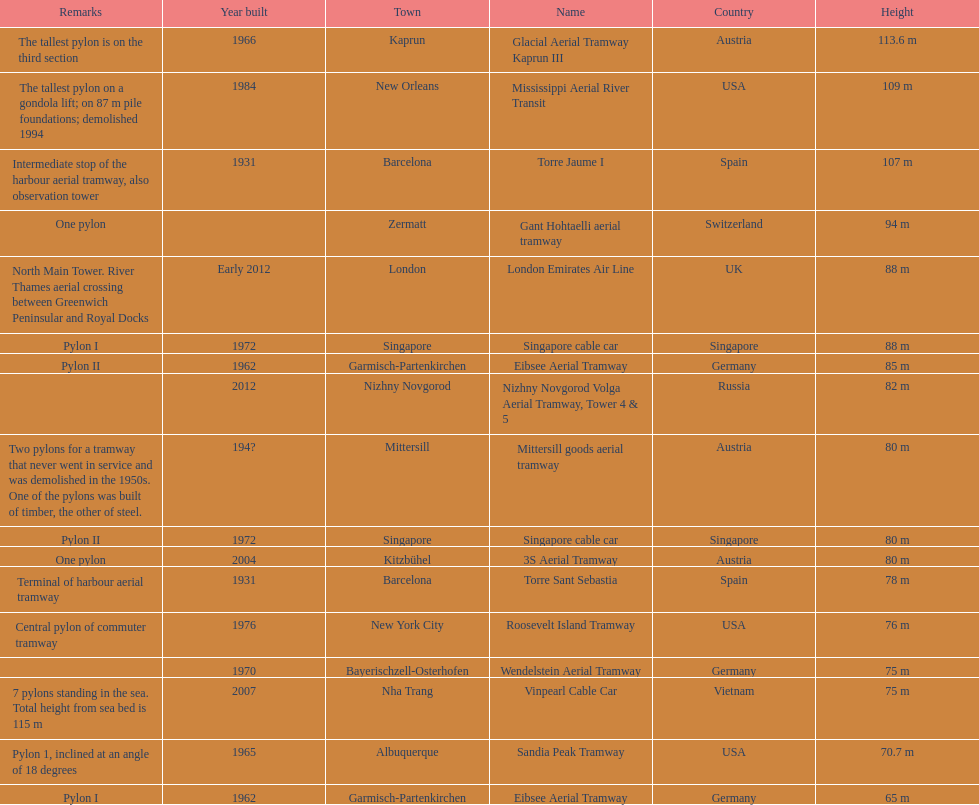What is the total number of tallest pylons in austria? 3. 